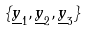<formula> <loc_0><loc_0><loc_500><loc_500>\{ \underline { y } _ { 1 } , \underline { y } _ { 2 } , \underline { y } _ { 3 } \}</formula> 